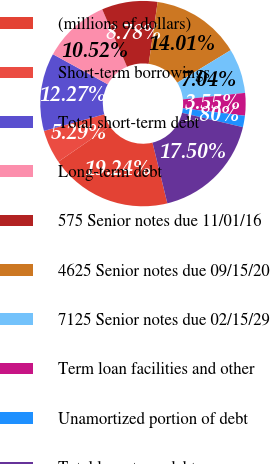Convert chart to OTSL. <chart><loc_0><loc_0><loc_500><loc_500><pie_chart><fcel>(millions of dollars)<fcel>Short-term borrowings<fcel>Total short-term debt<fcel>Long-term debt<fcel>575 Senior notes due 11/01/16<fcel>4625 Senior notes due 09/15/20<fcel>7125 Senior notes due 02/15/29<fcel>Term loan facilities and other<fcel>Unamortized portion of debt<fcel>Total long-term debt<nl><fcel>19.24%<fcel>5.29%<fcel>12.27%<fcel>10.52%<fcel>8.78%<fcel>14.01%<fcel>7.04%<fcel>3.55%<fcel>1.8%<fcel>17.5%<nl></chart> 